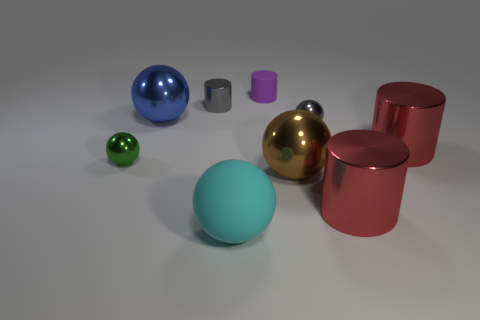Can you tell if the objects are set up randomly or if there is a pattern? The arrangement of objects appears random with no discernible pattern. The objects differ in size and are spread out, which suggests a casual placement rather than a deliberate configuration. 